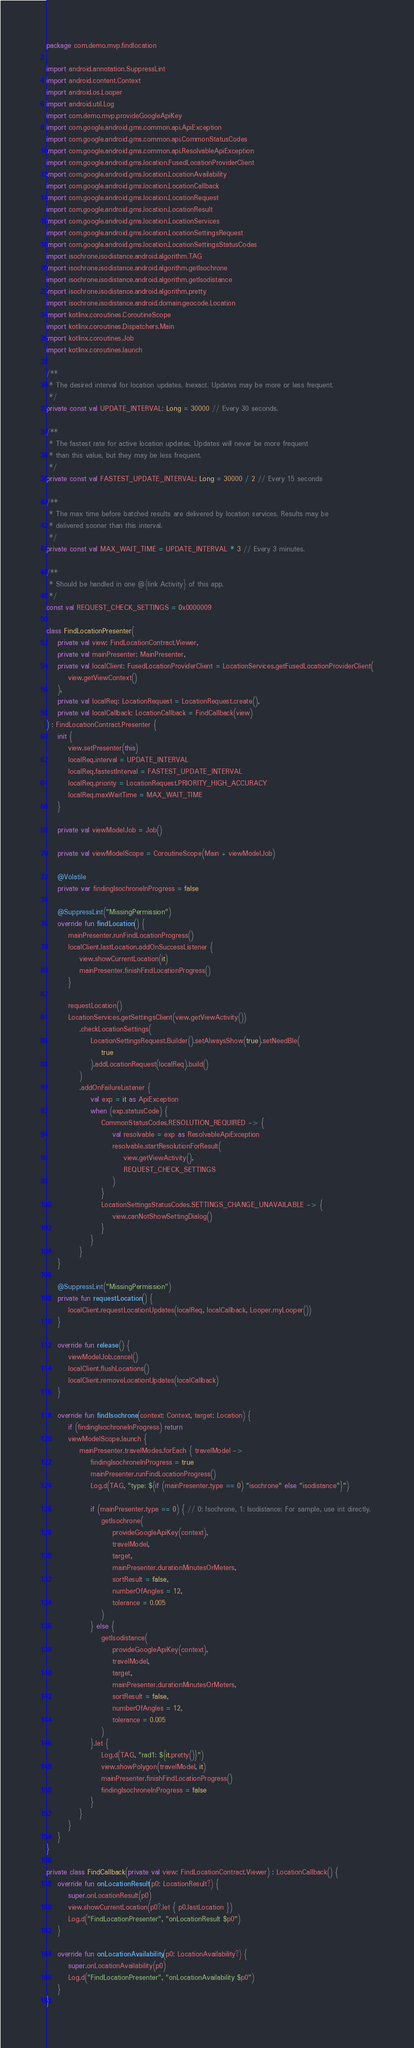<code> <loc_0><loc_0><loc_500><loc_500><_Kotlin_>package com.demo.mvp.findlocation

import android.annotation.SuppressLint
import android.content.Context
import android.os.Looper
import android.util.Log
import com.demo.mvp.provideGoogleApiKey
import com.google.android.gms.common.api.ApiException
import com.google.android.gms.common.api.CommonStatusCodes
import com.google.android.gms.common.api.ResolvableApiException
import com.google.android.gms.location.FusedLocationProviderClient
import com.google.android.gms.location.LocationAvailability
import com.google.android.gms.location.LocationCallback
import com.google.android.gms.location.LocationRequest
import com.google.android.gms.location.LocationResult
import com.google.android.gms.location.LocationServices
import com.google.android.gms.location.LocationSettingsRequest
import com.google.android.gms.location.LocationSettingsStatusCodes
import isochrone.isodistance.android.algorithm.TAG
import isochrone.isodistance.android.algorithm.getIsochrone
import isochrone.isodistance.android.algorithm.getIsodistance
import isochrone.isodistance.android.algorithm.pretty
import isochrone.isodistance.android.domain.geocode.Location
import kotlinx.coroutines.CoroutineScope
import kotlinx.coroutines.Dispatchers.Main
import kotlinx.coroutines.Job
import kotlinx.coroutines.launch

/**
 * The desired interval for location updates. Inexact. Updates may be more or less frequent.
 */
private const val UPDATE_INTERVAL: Long = 30000 // Every 30 seconds.

/**
 * The fastest rate for active location updates. Updates will never be more frequent
 * than this value, but they may be less frequent.
 */
private const val FASTEST_UPDATE_INTERVAL: Long = 30000 / 2 // Every 15 seconds

/**
 * The max time before batched results are delivered by location services. Results may be
 * delivered sooner than this interval.
 */
private const val MAX_WAIT_TIME = UPDATE_INTERVAL * 3 // Every 3 minutes.

/**
 * Should be handled in one @{link Activity} of this app.
 */
const val REQUEST_CHECK_SETTINGS = 0x0000009

class FindLocationPresenter(
    private val view: FindLocationContract.Viewer,
    private val mainPresenter: MainPresenter,
    private val localClient: FusedLocationProviderClient = LocationServices.getFusedLocationProviderClient(
        view.getViewContext()
    ),
    private val localReq: LocationRequest = LocationRequest.create(),
    private val localCallback: LocationCallback = FindCallback(view)
) : FindLocationContract.Presenter {
    init {
        view.setPresenter(this)
        localReq.interval = UPDATE_INTERVAL
        localReq.fastestInterval = FASTEST_UPDATE_INTERVAL
        localReq.priority = LocationRequest.PRIORITY_HIGH_ACCURACY
        localReq.maxWaitTime = MAX_WAIT_TIME
    }

    private val viewModelJob = Job()

    private val viewModelScope = CoroutineScope(Main + viewModelJob)

    @Volatile
    private var findingIsochroneInProgress = false

    @SuppressLint("MissingPermission")
    override fun findLocation() {
        mainPresenter.runFindLocationProgress()
        localClient.lastLocation.addOnSuccessListener {
            view.showCurrentLocation(it)
            mainPresenter.finishFindLocationProgress()
        }

        requestLocation()
        LocationServices.getSettingsClient(view.getViewActivity())
            .checkLocationSettings(
                LocationSettingsRequest.Builder().setAlwaysShow(true).setNeedBle(
                    true
                ).addLocationRequest(localReq).build()
            )
            .addOnFailureListener {
                val exp = it as ApiException
                when (exp.statusCode) {
                    CommonStatusCodes.RESOLUTION_REQUIRED -> {
                        val resolvable = exp as ResolvableApiException
                        resolvable.startResolutionForResult(
                            view.getViewActivity(),
                            REQUEST_CHECK_SETTINGS
                        )
                    }
                    LocationSettingsStatusCodes.SETTINGS_CHANGE_UNAVAILABLE -> {
                        view.canNotShowSettingDialog()
                    }
                }
            }
    }

    @SuppressLint("MissingPermission")
    private fun requestLocation() {
        localClient.requestLocationUpdates(localReq, localCallback, Looper.myLooper())
    }

    override fun release() {
        viewModelJob.cancel()
        localClient.flushLocations()
        localClient.removeLocationUpdates(localCallback)
    }

    override fun findIsochrone(context: Context, target: Location) {
        if (findingIsochroneInProgress) return
        viewModelScope.launch {
            mainPresenter.travelModes.forEach { travelModel ->
                findingIsochroneInProgress = true
                mainPresenter.runFindLocationProgress()
                Log.d(TAG, "type: ${if (mainPresenter.type == 0) "isochrone" else "isodistance"}")

                if (mainPresenter.type == 0) { // 0: Isochrone, 1: Isodistance: For sample, use int directly.
                    getIsochrone(
                        provideGoogleApiKey(context),
                        travelModel,
                        target,
                        mainPresenter.durationMinutesOrMeters,
                        sortResult = false,
                        numberOfAngles = 12,
                        tolerance = 0.005
                    )
                } else {
                    getIsodistance(
                        provideGoogleApiKey(context),
                        travelModel,
                        target,
                        mainPresenter.durationMinutesOrMeters,
                        sortResult = false,
                        numberOfAngles = 12,
                        tolerance = 0.005
                    )
                }.let {
                    Log.d(TAG, "rad1: ${it.pretty()}")
                    view.showPolygon(travelModel, it)
                    mainPresenter.finishFindLocationProgress()
                    findingIsochroneInProgress = false
                }
            }
        }
    }
}

private class FindCallback(private val view: FindLocationContract.Viewer) : LocationCallback() {
    override fun onLocationResult(p0: LocationResult?) {
        super.onLocationResult(p0)
        view.showCurrentLocation(p0?.let { p0.lastLocation })
        Log.d("FindLocationPresenter", "onLocationResult $p0")
    }

    override fun onLocationAvailability(p0: LocationAvailability?) {
        super.onLocationAvailability(p0)
        Log.d("FindLocationPresenter", "onLocationAvailability $p0")
    }
}</code> 